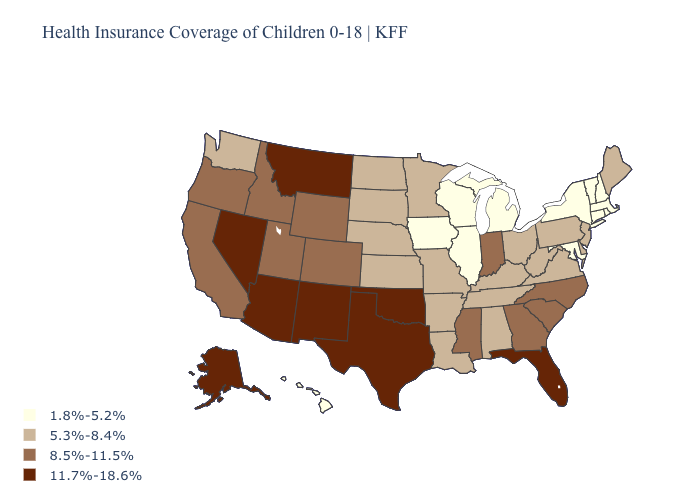Does Oregon have the same value as West Virginia?
Write a very short answer. No. Name the states that have a value in the range 5.3%-8.4%?
Keep it brief. Alabama, Arkansas, Delaware, Kansas, Kentucky, Louisiana, Maine, Minnesota, Missouri, Nebraska, New Jersey, North Dakota, Ohio, Pennsylvania, South Dakota, Tennessee, Virginia, Washington, West Virginia. What is the value of Kansas?
Short answer required. 5.3%-8.4%. Does Alaska have the highest value in the USA?
Concise answer only. Yes. How many symbols are there in the legend?
Give a very brief answer. 4. What is the lowest value in the MidWest?
Write a very short answer. 1.8%-5.2%. What is the highest value in the USA?
Give a very brief answer. 11.7%-18.6%. Does Wyoming have the same value as Delaware?
Quick response, please. No. Which states have the highest value in the USA?
Quick response, please. Alaska, Arizona, Florida, Montana, Nevada, New Mexico, Oklahoma, Texas. Which states have the lowest value in the South?
Quick response, please. Maryland. Does Montana have the same value as Hawaii?
Concise answer only. No. What is the value of Alabama?
Write a very short answer. 5.3%-8.4%. Does the map have missing data?
Keep it brief. No. Among the states that border Florida , does Georgia have the highest value?
Keep it brief. Yes. Name the states that have a value in the range 1.8%-5.2%?
Concise answer only. Connecticut, Hawaii, Illinois, Iowa, Maryland, Massachusetts, Michigan, New Hampshire, New York, Rhode Island, Vermont, Wisconsin. 